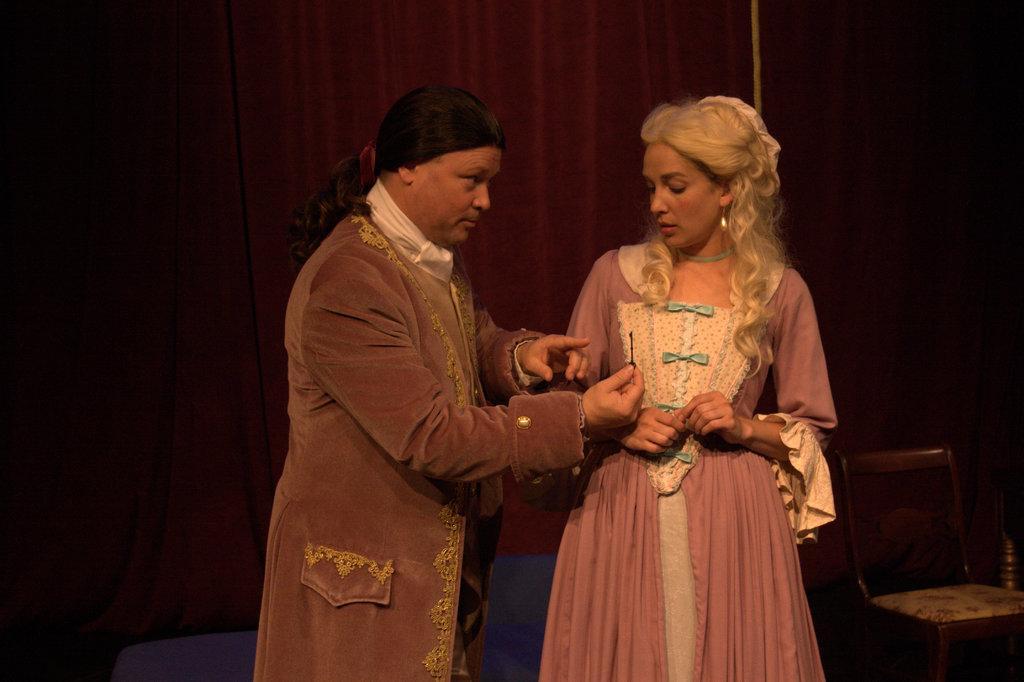Describe this image in one or two sentences. In this image, there are two persons standing and wearing colorful clothes. There is a chair in the bottom right of the image. 